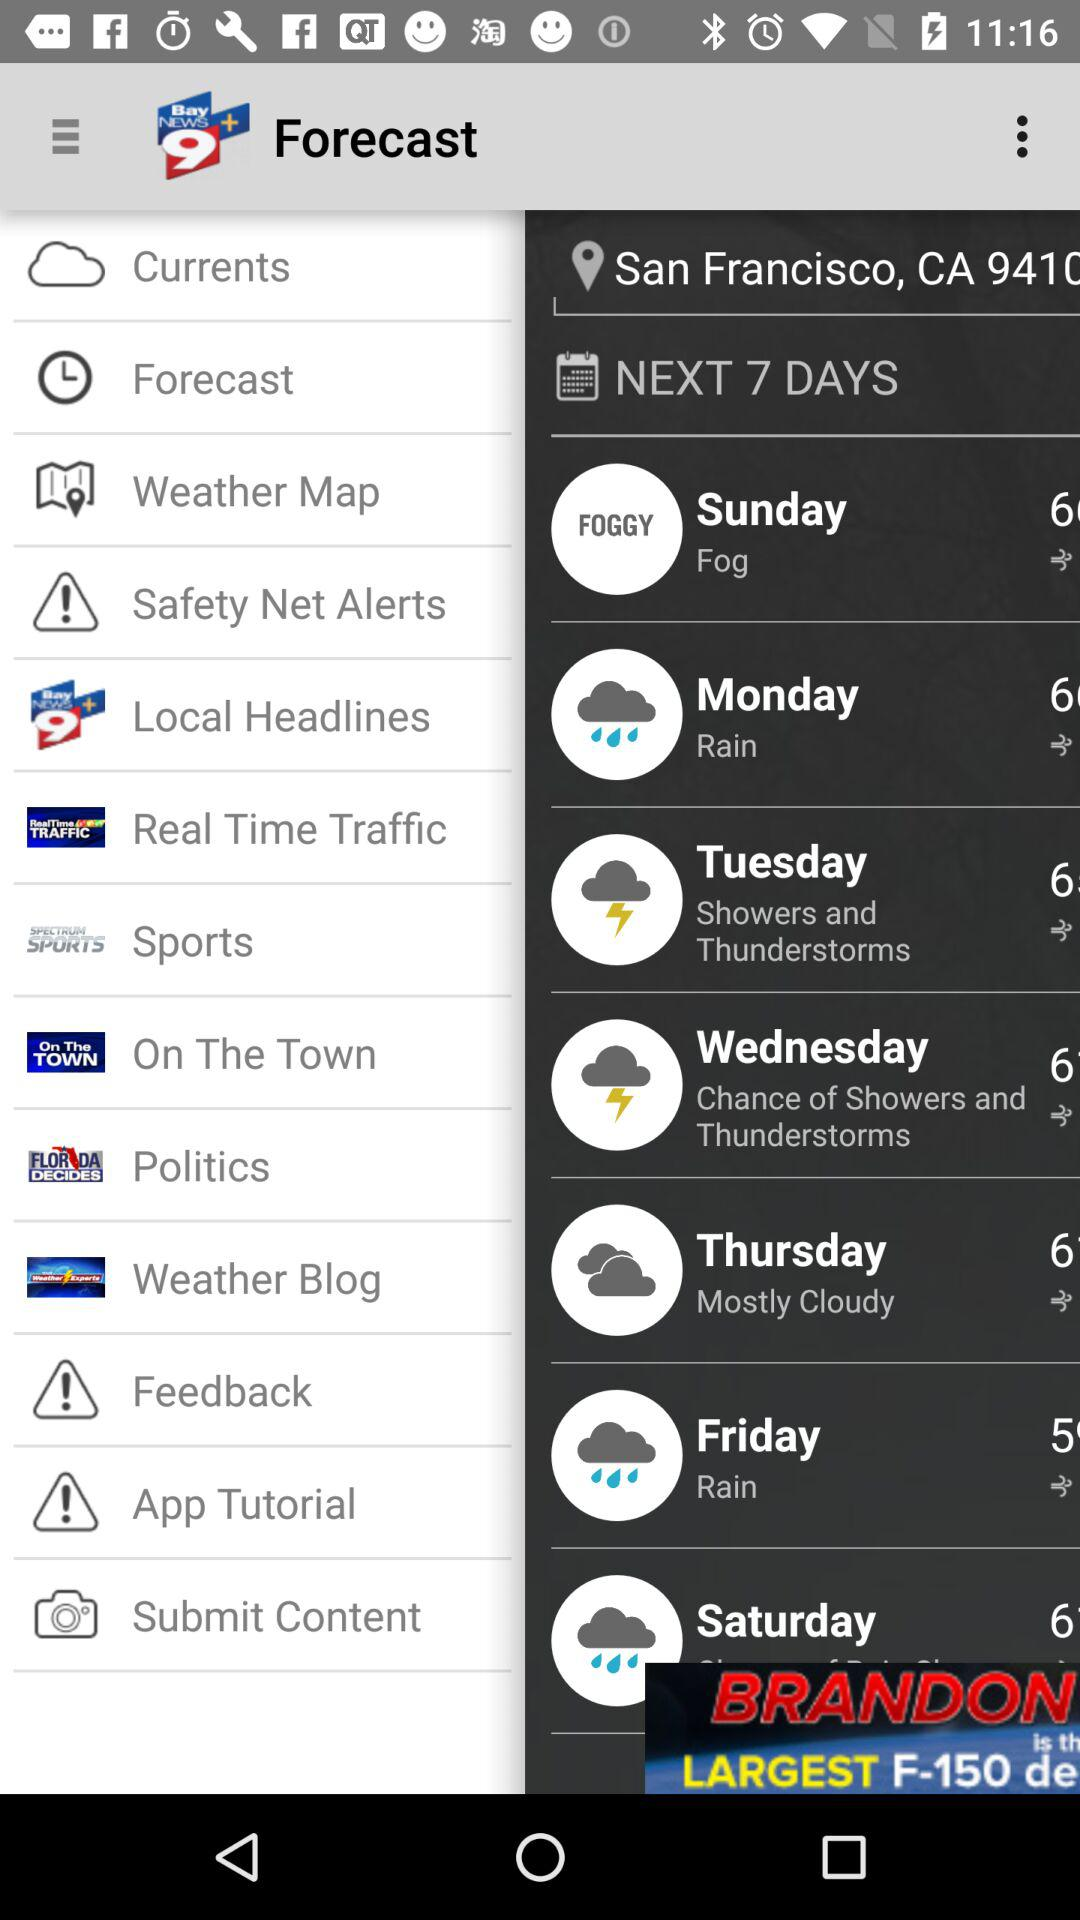What is the location? The location is San Francisco, CA 9410. 